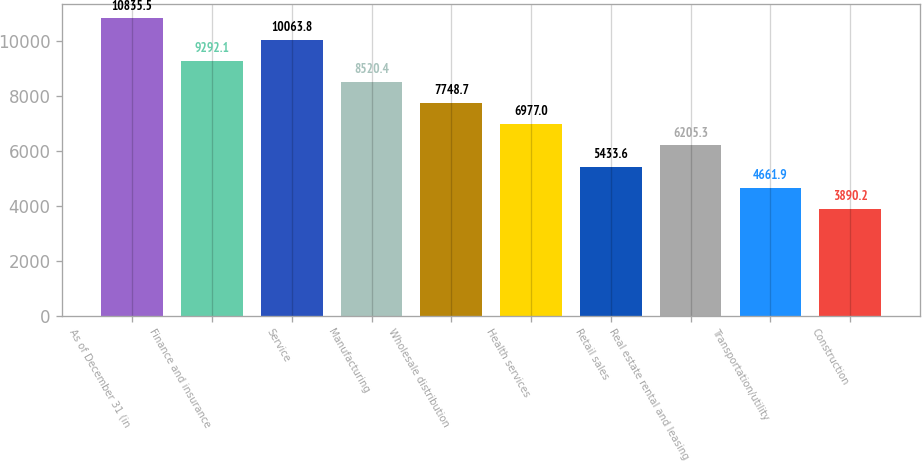Convert chart to OTSL. <chart><loc_0><loc_0><loc_500><loc_500><bar_chart><fcel>As of December 31 (in<fcel>Finance and insurance<fcel>Service<fcel>Manufacturing<fcel>Wholesale distribution<fcel>Health services<fcel>Retail sales<fcel>Real estate rental and leasing<fcel>Transportation/utility<fcel>Construction<nl><fcel>10835.5<fcel>9292.1<fcel>10063.8<fcel>8520.4<fcel>7748.7<fcel>6977<fcel>5433.6<fcel>6205.3<fcel>4661.9<fcel>3890.2<nl></chart> 